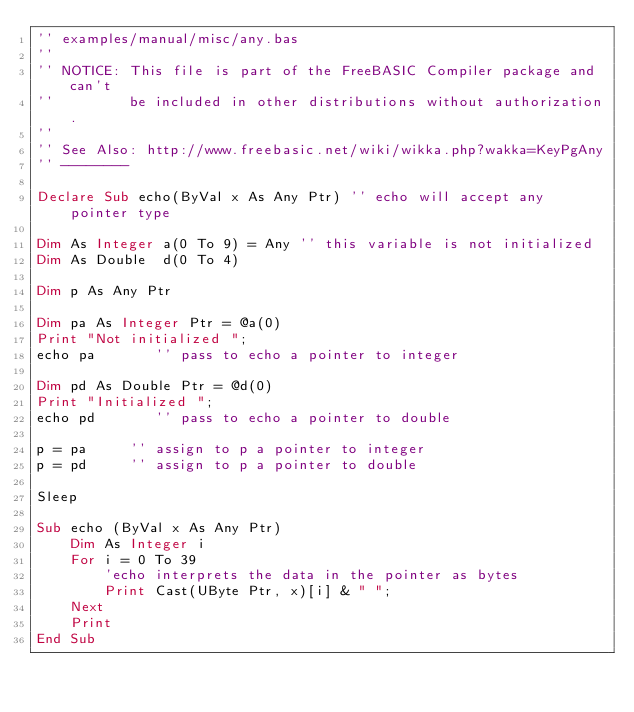<code> <loc_0><loc_0><loc_500><loc_500><_VisualBasic_>'' examples/manual/misc/any.bas
''
'' NOTICE: This file is part of the FreeBASIC Compiler package and can't
''         be included in other distributions without authorization.
''
'' See Also: http://www.freebasic.net/wiki/wikka.php?wakka=KeyPgAny
'' --------

Declare Sub echo(ByVal x As Any Ptr) '' echo will accept any pointer type

Dim As Integer a(0 To 9) = Any '' this variable is not initialized
Dim As Double  d(0 To 4)

Dim p As Any Ptr

Dim pa As Integer Ptr = @a(0)
Print "Not initialized ";
echo pa       '' pass to echo a pointer to integer

Dim pd As Double Ptr = @d(0)
Print "Initialized ";
echo pd       '' pass to echo a pointer to double

p = pa     '' assign to p a pointer to integer
p = pd     '' assign to p a pointer to double      

Sleep

Sub echo (ByVal x As Any Ptr)
	Dim As Integer i
	For i = 0 To 39
		'echo interprets the data in the pointer as bytes
		Print Cast(UByte Ptr, x)[i] & " ";
	Next
	Print
End Sub
</code> 